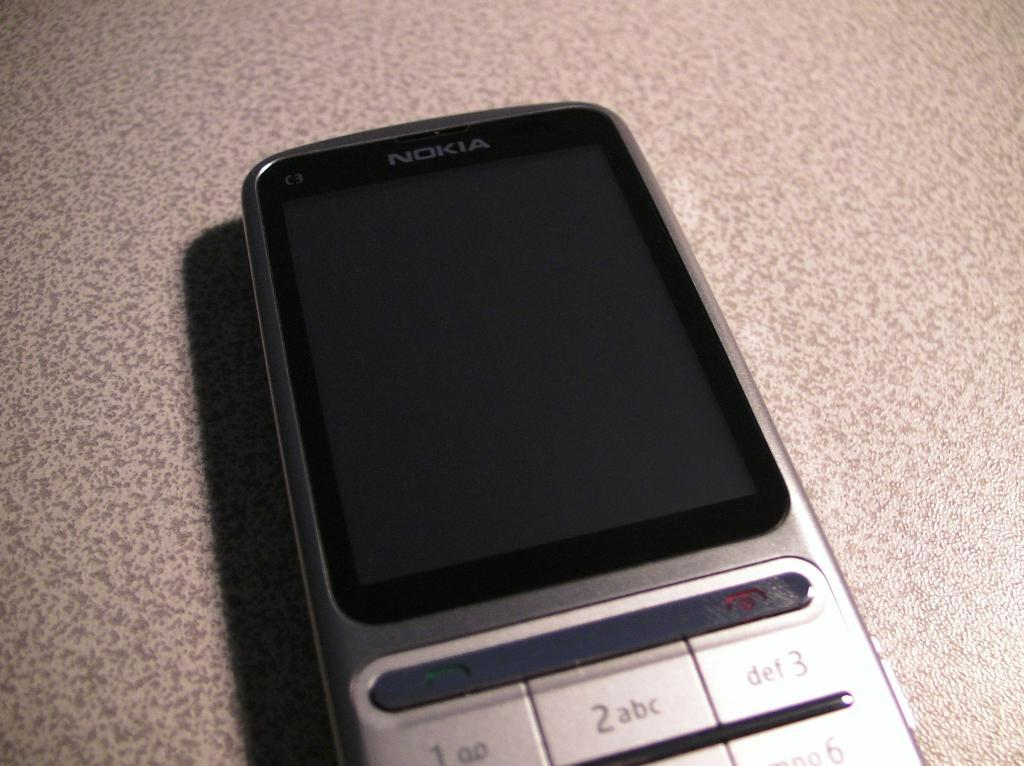<image>
Present a compact description of the photo's key features. A Nokia cell phone is lying on a textured surface. 